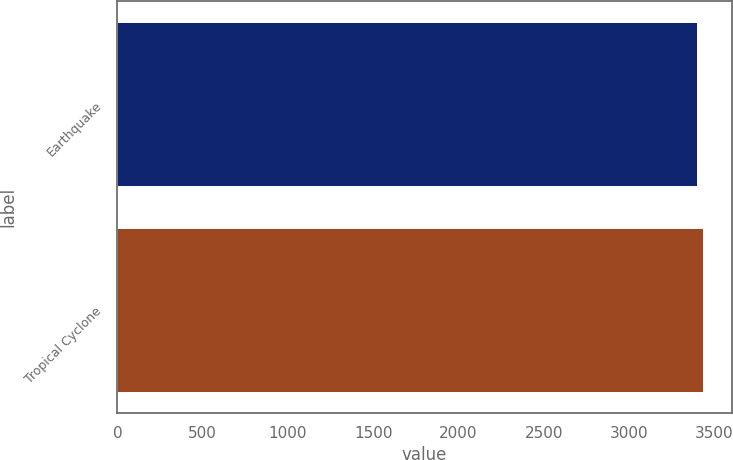Convert chart to OTSL. <chart><loc_0><loc_0><loc_500><loc_500><bar_chart><fcel>Earthquake<fcel>Tropical Cyclone<nl><fcel>3397<fcel>3430<nl></chart> 